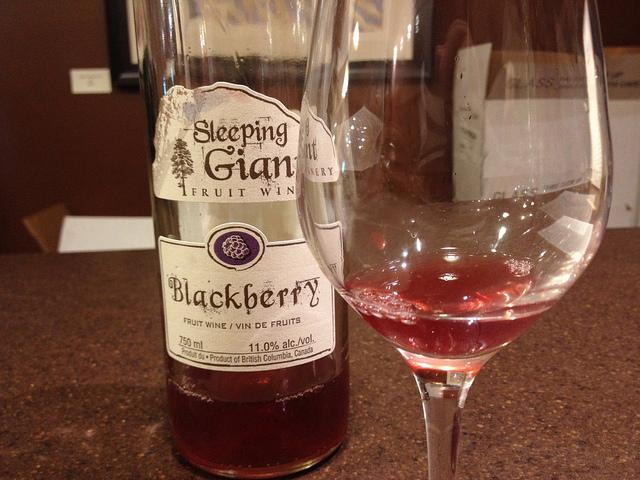What is the percent of alcohol?

Choices:
A) five
B) 11
C) 60
D) 80 11 